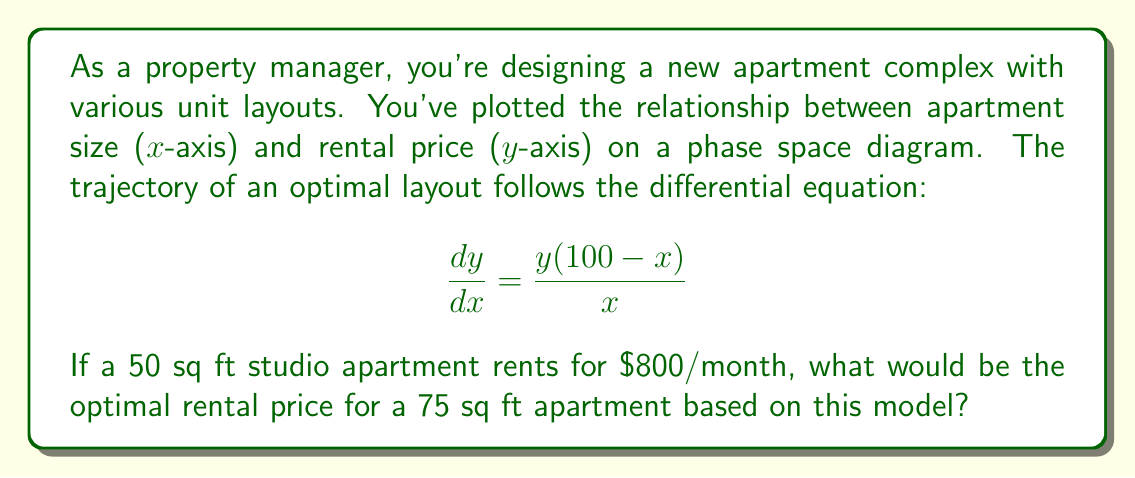Help me with this question. Let's approach this step-by-step:

1) The given differential equation is:

   $$\frac{dy}{dx} = \frac{y(100-x)}{x}$$

2) To solve this, we can separate the variables:

   $$\frac{dy}{y} = \frac{100-x}{x}dx$$

3) Integrating both sides:

   $$\int \frac{dy}{y} = \int \frac{100-x}{x}dx$$

4) This gives us:

   $$\ln|y| = 100\ln|x| - x + C$$

5) Taking the exponential of both sides:

   $$y = Cx^{100}e^{-x}$$

6) We're given that when x = 50 (sq ft), y = 800 ($/month). Let's use this to find C:

   $$800 = C(50)^{100}e^{-50}$$
   $$C = \frac{800}{50^{100}e^{-50}}$$

7) Now we have our specific solution:

   $$y = \frac{800}{50^{100}e^{-50}}x^{100}e^{-x}$$

8) To find the optimal rent for a 75 sq ft apartment, we plug in x = 75:

   $$y = \frac{800}{50^{100}e^{-50}}(75)^{100}e^{-75}$$

9) Calculating this (you may need a computer for this step):

   $$y \approx 1199.62$$

Therefore, the optimal rental price for a 75 sq ft apartment would be approximately $1199.62 per month.
Answer: $1199.62/month 